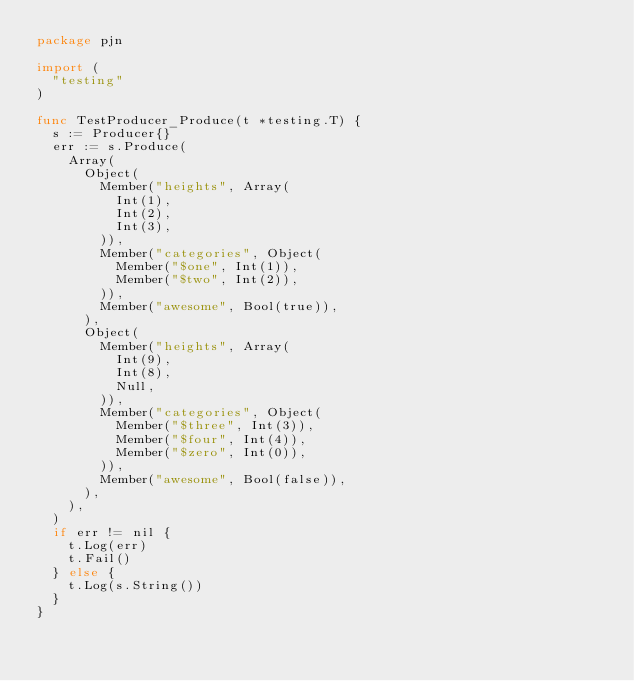<code> <loc_0><loc_0><loc_500><loc_500><_Go_>package pjn

import (
	"testing"
)

func TestProducer_Produce(t *testing.T) {
	s := Producer{}
	err := s.Produce(
		Array(
			Object(
				Member("heights", Array(
					Int(1),
					Int(2),
					Int(3),
				)),
				Member("categories", Object(
					Member("$one", Int(1)),
					Member("$two", Int(2)),
				)),
				Member("awesome", Bool(true)),
			),
			Object(
				Member("heights", Array(
					Int(9),
					Int(8),
					Null,
				)),
				Member("categories", Object(
					Member("$three", Int(3)),
					Member("$four", Int(4)),
					Member("$zero", Int(0)),
				)),
				Member("awesome", Bool(false)),
			),
		),
	)
	if err != nil {
		t.Log(err)
		t.Fail()
	} else {
		t.Log(s.String())
	}
}
</code> 